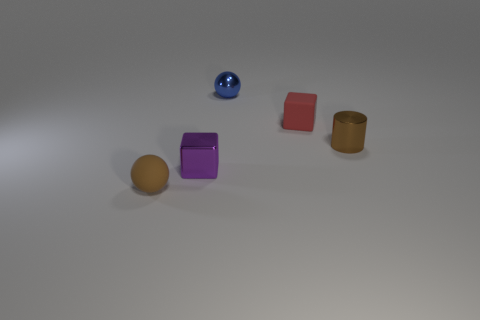Subtract all brown spheres. How many spheres are left? 1 Add 4 gray rubber cylinders. How many objects exist? 9 Subtract all cylinders. How many objects are left? 4 Subtract 2 cubes. How many cubes are left? 0 Subtract all cyan spheres. How many red blocks are left? 1 Add 2 small matte blocks. How many small matte blocks are left? 3 Add 4 big metal cubes. How many big metal cubes exist? 4 Subtract 0 purple spheres. How many objects are left? 5 Subtract all blue cylinders. Subtract all purple spheres. How many cylinders are left? 1 Subtract all small metal objects. Subtract all matte objects. How many objects are left? 0 